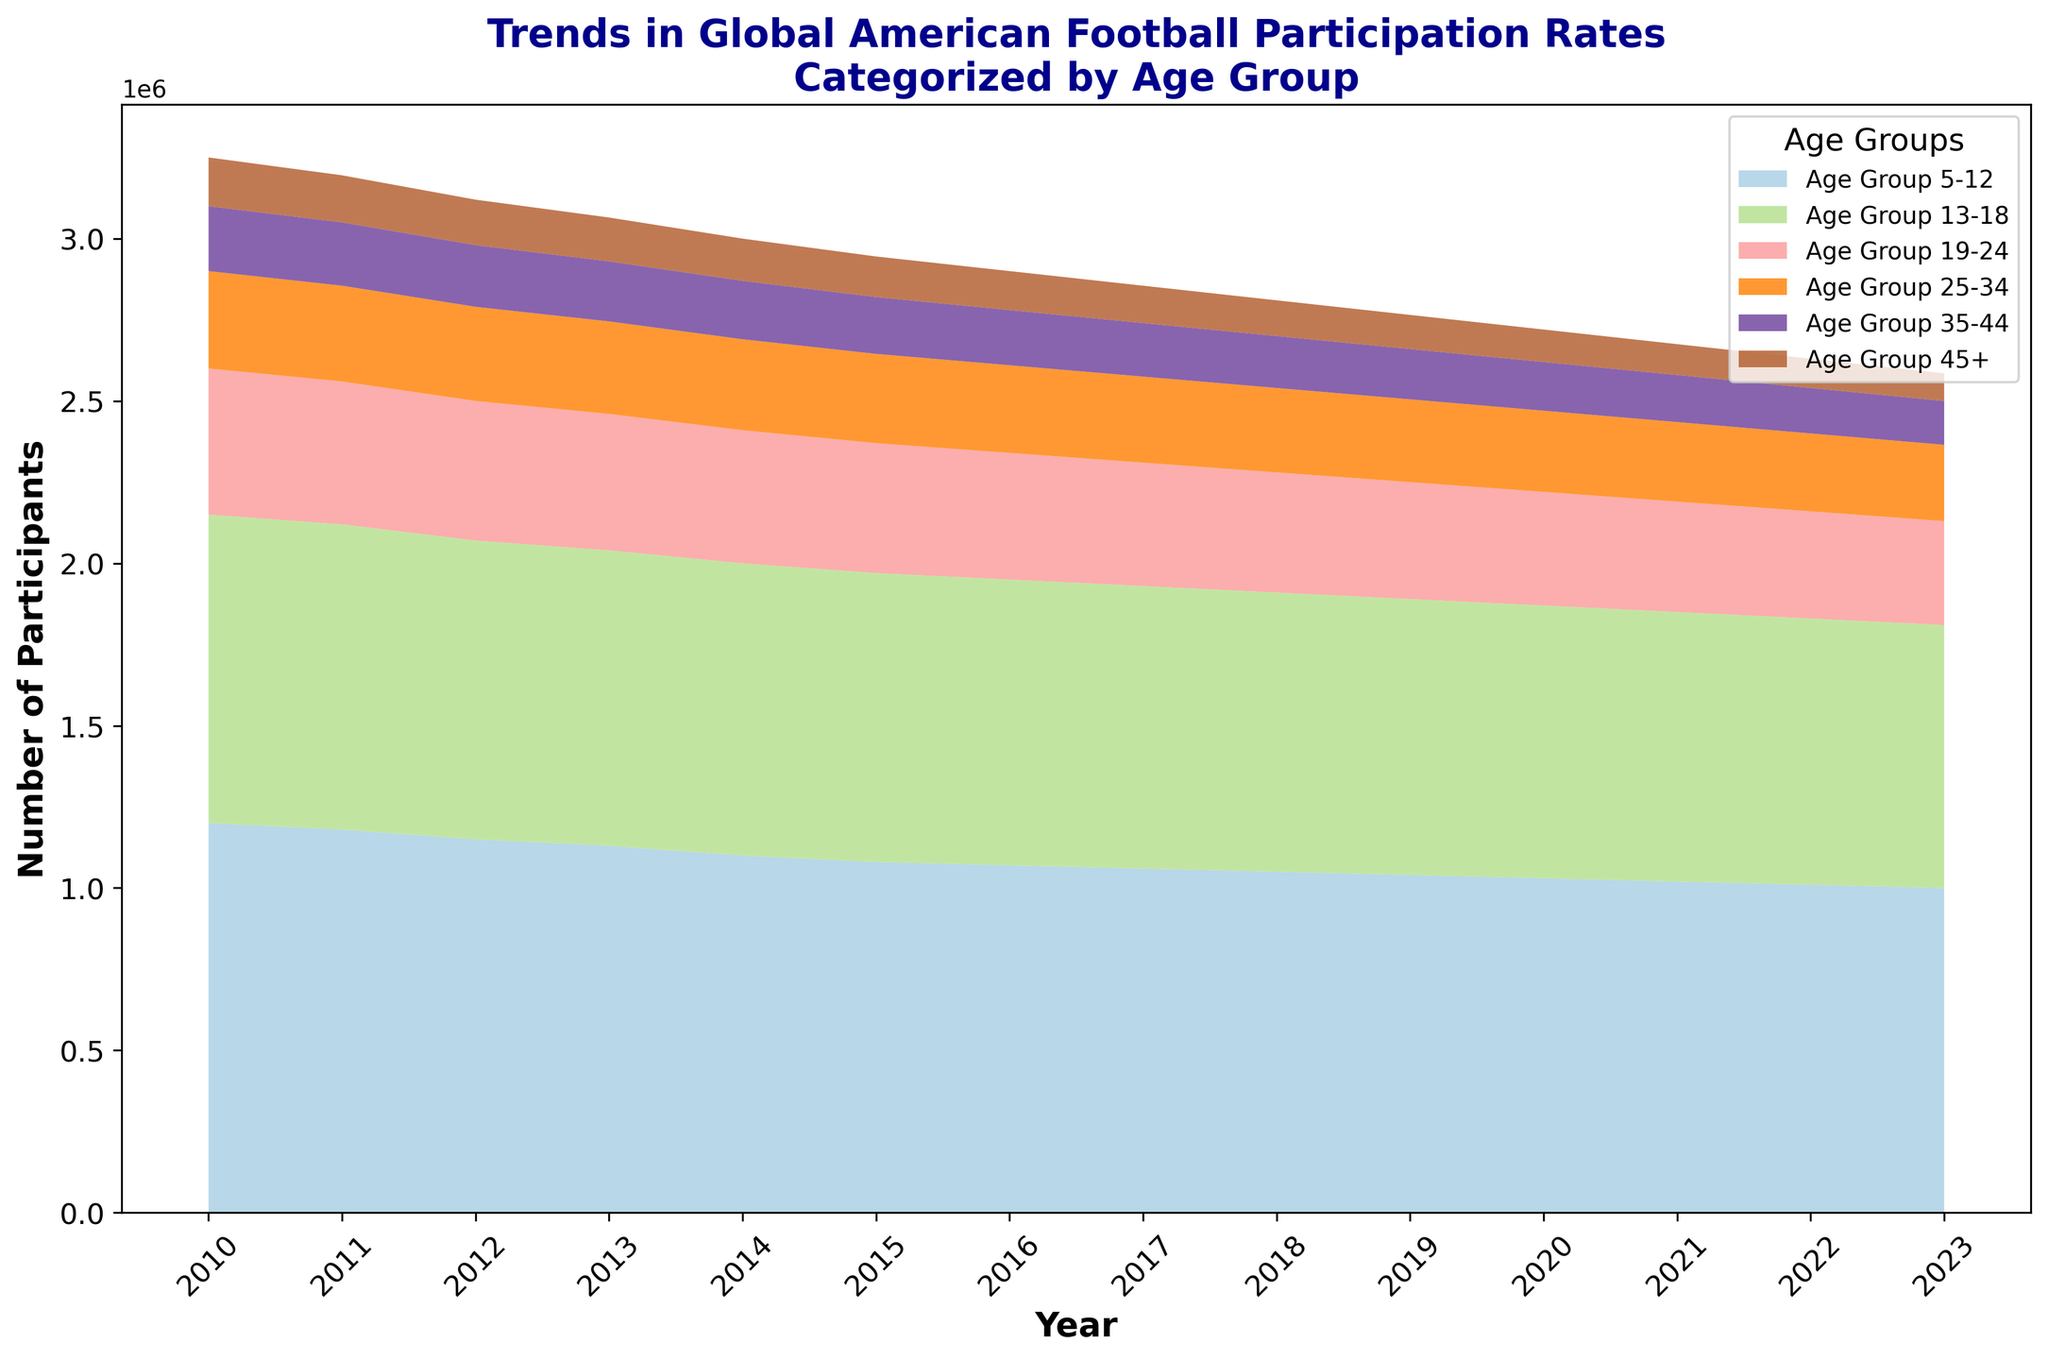What trend is observed in the participation rates for the age group 5-12 from 2010 to 2023? The chart shows a decreasing trend in participation rates for the age group 5-12 over the years. Starting from 1,200,000 participants in 2010, it steadily declines to 1,000,000 in 2023.
Answer: Decreasing trend Which age group has the least number of participants across all years? Reviewing the chart, the age group 45+ consistently has the lowest participation rates from 2010 to 2023. In 2010, it starts at 150,000 and declines to 85,000 by 2023.
Answer: Age group 45+ How does the participation rate of the age group 13-18 in 2010 compare to 2023? The participation rate of the age group 13-18 in 2010 was 950,000 participants. By 2023, it had declined to 810,000 participants. Thus, the rate decreased by 140,000 participants over the period.
Answer: It decreased by 140,000 participants In which year does the age group 19-24 hit the lowest number of participants, and what is that number? The lowest number of participants for the age group 19-24 is seen in 2023, with a value of 320,000.
Answer: 2023, 320,000 Compare the heights of the areas representing the age groups 25-34 and 35-44 in 2015. Which is taller? In 2015, the height of the area representing the age group 25-34 is taller than that of the 35-44 age group. The figures are 275,000 and 175,000, respectively.
Answer: Age group 25-34 is taller What is the combined total participation of all age groups in 2020? To find the combined total participation in 2020, sum the participant numbers for all age groups: 1,030,000 (5-12) + 840,000 (13-18) + 350,000 (19-24) + 250,000 (25-34) + 150,000 (35-44) + 100,000 (45+) = 2,720,000.
Answer: 2,720,000 What is the average annual change in participation rates for the age group 5-12 between 2010 and 2023? First, find the total change in participation: 1,000,000 (2023) - 1,200,000 (2010) = -200,000. Next, calculate the average annual change: -200,000 / 13 (years) = -15,384.62 participants per year.
Answer: -15,384.62 participants per year Which age group witnessed the largest decrease in participation from 2010 to 2023? Subtract the 2023 value from the 2010 value for each age group to find the decreases: 
- 5-12: 1,200,000 - 1,000,000 = 200,000
- 13-18: 950,000 - 810,000 = 140,000
- 19-24: 450,000 - 320,000 = 130,000
- 25-34: 300,000 - 235,000 = 65,000
- 35-44: 200,000 - 135,000 = 65,000
- 45+: 150,000 - 85,000 = 65,000
The age group 5-12 experienced the largest decrease.
Answer: Age group 5-12 In which years do the age groups 25-34 and 35-44 have equal participation rates? The chart shows that in 2010, the participation rates for the age groups 25-34 and 35-44 were equal, both at 200,000 participants.
Answer: 2010 